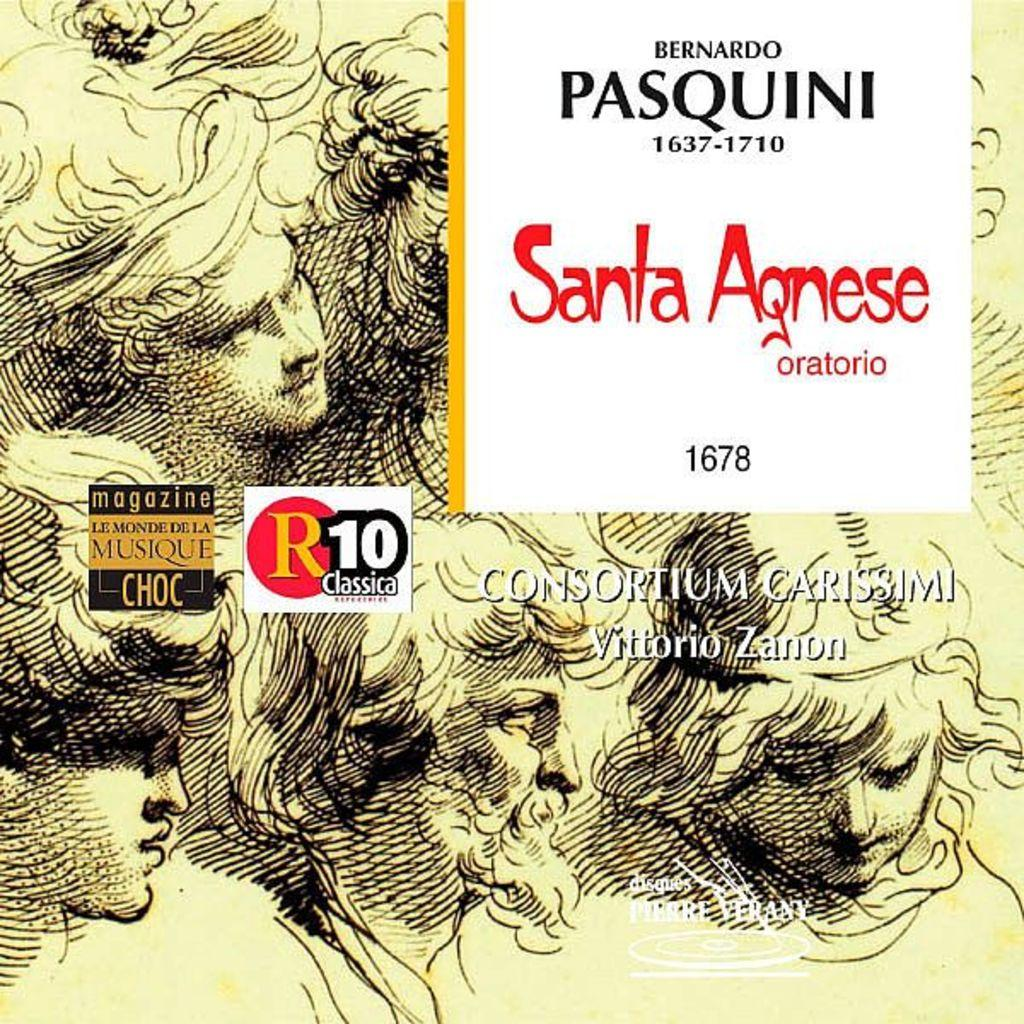What is featured in the image? There is a poster in the image. What can be found on the poster? The poster contains text and paintings of persons. Reasoning: Leting: Let's think step by step in order to produce the conversation. We start by identifying the main subject in the image, which is the poster. Then, we expand the conversation to include other details about the poster, such as the presence of text and paintings of persons. Each question is designed to elicit a specific detail about the image that is known from the provided facts. Absurd Question/Answer: What type of stocking is being worn by the jellyfish in the image? There are no jellyfish or stockings present in the image; the poster contains paintings of persons. How many cups are being held by the persons in the image? There are no cups present in the image; the poster contains paintings of persons holding nothing. 